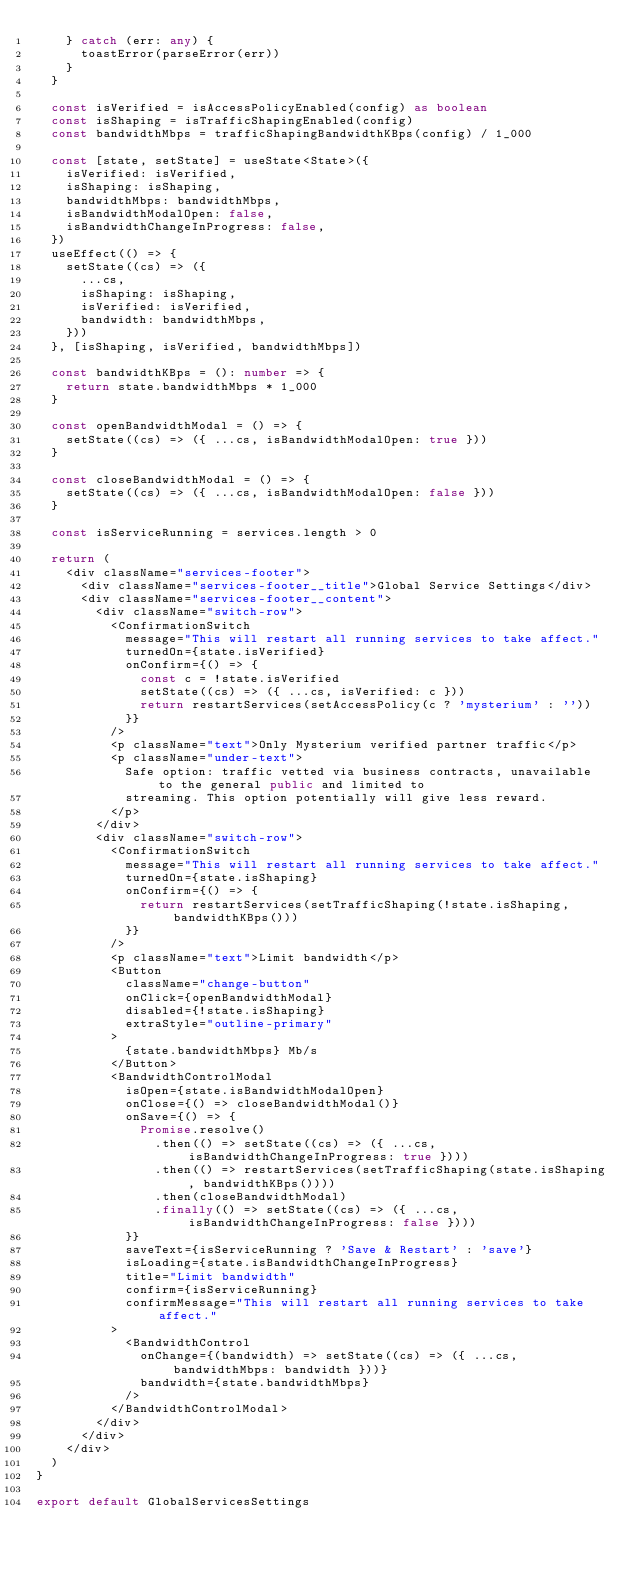<code> <loc_0><loc_0><loc_500><loc_500><_TypeScript_>    } catch (err: any) {
      toastError(parseError(err))
    }
  }

  const isVerified = isAccessPolicyEnabled(config) as boolean
  const isShaping = isTrafficShapingEnabled(config)
  const bandwidthMbps = trafficShapingBandwidthKBps(config) / 1_000

  const [state, setState] = useState<State>({
    isVerified: isVerified,
    isShaping: isShaping,
    bandwidthMbps: bandwidthMbps,
    isBandwidthModalOpen: false,
    isBandwidthChangeInProgress: false,
  })
  useEffect(() => {
    setState((cs) => ({
      ...cs,
      isShaping: isShaping,
      isVerified: isVerified,
      bandwidth: bandwidthMbps,
    }))
  }, [isShaping, isVerified, bandwidthMbps])

  const bandwidthKBps = (): number => {
    return state.bandwidthMbps * 1_000
  }

  const openBandwidthModal = () => {
    setState((cs) => ({ ...cs, isBandwidthModalOpen: true }))
  }

  const closeBandwidthModal = () => {
    setState((cs) => ({ ...cs, isBandwidthModalOpen: false }))
  }

  const isServiceRunning = services.length > 0

  return (
    <div className="services-footer">
      <div className="services-footer__title">Global Service Settings</div>
      <div className="services-footer__content">
        <div className="switch-row">
          <ConfirmationSwitch
            message="This will restart all running services to take affect."
            turnedOn={state.isVerified}
            onConfirm={() => {
              const c = !state.isVerified
              setState((cs) => ({ ...cs, isVerified: c }))
              return restartServices(setAccessPolicy(c ? 'mysterium' : ''))
            }}
          />
          <p className="text">Only Mysterium verified partner traffic</p>
          <p className="under-text">
            Safe option: traffic vetted via business contracts, unavailable to the general public and limited to
            streaming. This option potentially will give less reward.
          </p>
        </div>
        <div className="switch-row">
          <ConfirmationSwitch
            message="This will restart all running services to take affect."
            turnedOn={state.isShaping}
            onConfirm={() => {
              return restartServices(setTrafficShaping(!state.isShaping, bandwidthKBps()))
            }}
          />
          <p className="text">Limit bandwidth</p>
          <Button
            className="change-button"
            onClick={openBandwidthModal}
            disabled={!state.isShaping}
            extraStyle="outline-primary"
          >
            {state.bandwidthMbps} Mb/s
          </Button>
          <BandwidthControlModal
            isOpen={state.isBandwidthModalOpen}
            onClose={() => closeBandwidthModal()}
            onSave={() => {
              Promise.resolve()
                .then(() => setState((cs) => ({ ...cs, isBandwidthChangeInProgress: true })))
                .then(() => restartServices(setTrafficShaping(state.isShaping, bandwidthKBps())))
                .then(closeBandwidthModal)
                .finally(() => setState((cs) => ({ ...cs, isBandwidthChangeInProgress: false })))
            }}
            saveText={isServiceRunning ? 'Save & Restart' : 'save'}
            isLoading={state.isBandwidthChangeInProgress}
            title="Limit bandwidth"
            confirm={isServiceRunning}
            confirmMessage="This will restart all running services to take affect."
          >
            <BandwidthControl
              onChange={(bandwidth) => setState((cs) => ({ ...cs, bandwidthMbps: bandwidth }))}
              bandwidth={state.bandwidthMbps}
            />
          </BandwidthControlModal>
        </div>
      </div>
    </div>
  )
}

export default GlobalServicesSettings
</code> 